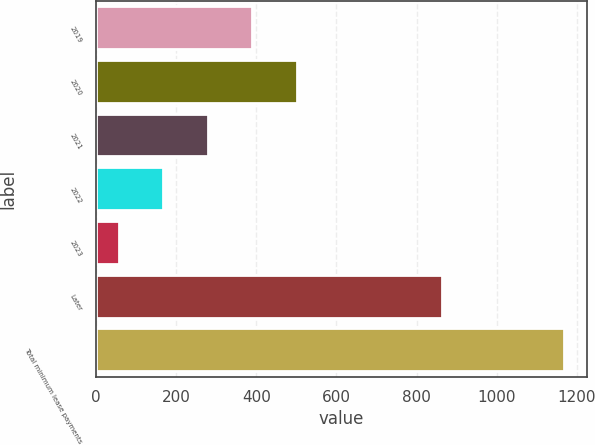Convert chart to OTSL. <chart><loc_0><loc_0><loc_500><loc_500><bar_chart><fcel>2019<fcel>2020<fcel>2021<fcel>2022<fcel>2023<fcel>Later<fcel>Total minimum lease payments<nl><fcel>390<fcel>501<fcel>279<fcel>168<fcel>57<fcel>864<fcel>1167<nl></chart> 